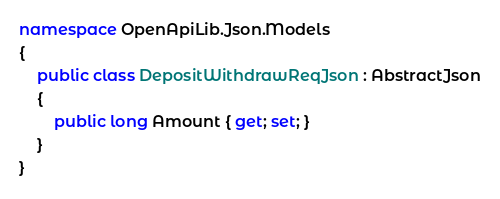Convert code to text. <code><loc_0><loc_0><loc_500><loc_500><_C#_>namespace OpenApiLib.Json.Models
{
	public class DepositWithdrawReqJson : AbstractJson
	{
		public long Amount { get; set; }
	}
}
</code> 